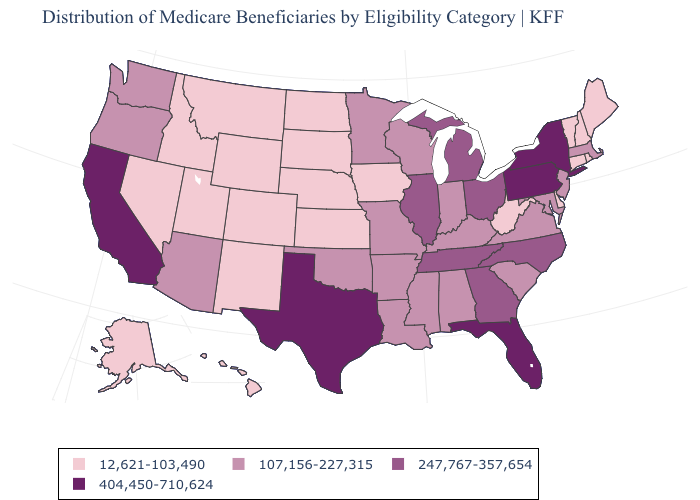Does Virginia have a higher value than Florida?
Give a very brief answer. No. What is the lowest value in the Northeast?
Concise answer only. 12,621-103,490. What is the value of Idaho?
Answer briefly. 12,621-103,490. Does New Jersey have the lowest value in the Northeast?
Give a very brief answer. No. Name the states that have a value in the range 404,450-710,624?
Be succinct. California, Florida, New York, Pennsylvania, Texas. What is the highest value in the USA?
Answer briefly. 404,450-710,624. Which states have the lowest value in the South?
Quick response, please. Delaware, West Virginia. Name the states that have a value in the range 404,450-710,624?
Keep it brief. California, Florida, New York, Pennsylvania, Texas. What is the lowest value in the USA?
Concise answer only. 12,621-103,490. Is the legend a continuous bar?
Keep it brief. No. Name the states that have a value in the range 12,621-103,490?
Concise answer only. Alaska, Colorado, Connecticut, Delaware, Hawaii, Idaho, Iowa, Kansas, Maine, Montana, Nebraska, Nevada, New Hampshire, New Mexico, North Dakota, Rhode Island, South Dakota, Utah, Vermont, West Virginia, Wyoming. Name the states that have a value in the range 12,621-103,490?
Quick response, please. Alaska, Colorado, Connecticut, Delaware, Hawaii, Idaho, Iowa, Kansas, Maine, Montana, Nebraska, Nevada, New Hampshire, New Mexico, North Dakota, Rhode Island, South Dakota, Utah, Vermont, West Virginia, Wyoming. Does Louisiana have a higher value than Maine?
Be succinct. Yes. Which states have the highest value in the USA?
Give a very brief answer. California, Florida, New York, Pennsylvania, Texas. Does Delaware have a lower value than Rhode Island?
Short answer required. No. 